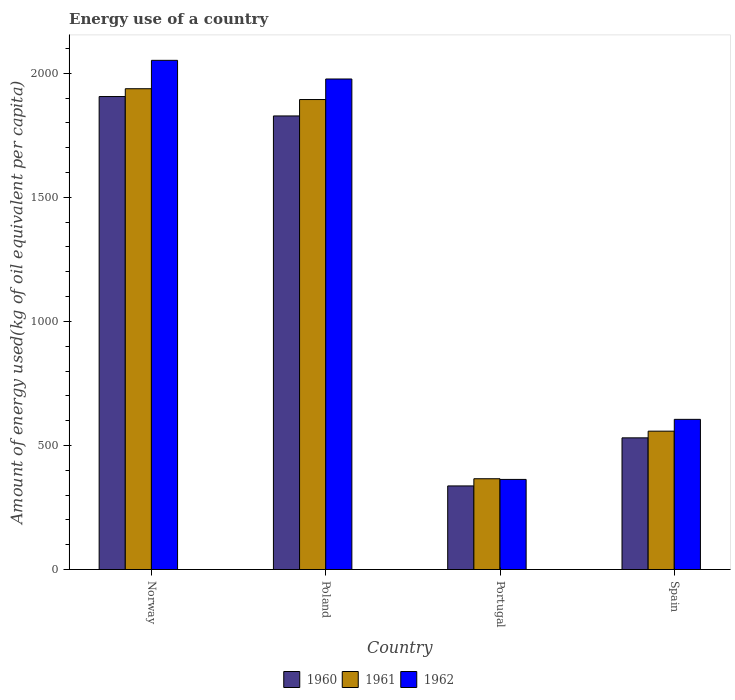How many groups of bars are there?
Give a very brief answer. 4. Are the number of bars per tick equal to the number of legend labels?
Your response must be concise. Yes. Are the number of bars on each tick of the X-axis equal?
Offer a terse response. Yes. How many bars are there on the 4th tick from the right?
Ensure brevity in your answer.  3. What is the label of the 3rd group of bars from the left?
Provide a short and direct response. Portugal. What is the amount of energy used in in 1961 in Poland?
Give a very brief answer. 1894.06. Across all countries, what is the maximum amount of energy used in in 1962?
Your answer should be compact. 2052.05. Across all countries, what is the minimum amount of energy used in in 1960?
Make the answer very short. 336.91. In which country was the amount of energy used in in 1962 minimum?
Make the answer very short. Portugal. What is the total amount of energy used in in 1961 in the graph?
Give a very brief answer. 4755.14. What is the difference between the amount of energy used in in 1962 in Poland and that in Portugal?
Your answer should be very brief. 1613.7. What is the difference between the amount of energy used in in 1962 in Poland and the amount of energy used in in 1960 in Spain?
Keep it short and to the point. 1446.19. What is the average amount of energy used in in 1961 per country?
Your answer should be very brief. 1188.79. What is the difference between the amount of energy used in of/in 1961 and amount of energy used in of/in 1960 in Poland?
Ensure brevity in your answer.  66.12. What is the ratio of the amount of energy used in in 1960 in Portugal to that in Spain?
Provide a short and direct response. 0.63. Is the amount of energy used in in 1961 in Poland less than that in Portugal?
Offer a terse response. No. What is the difference between the highest and the second highest amount of energy used in in 1962?
Provide a short and direct response. -75.19. What is the difference between the highest and the lowest amount of energy used in in 1960?
Ensure brevity in your answer.  1569.26. In how many countries, is the amount of energy used in in 1960 greater than the average amount of energy used in in 1960 taken over all countries?
Your answer should be very brief. 2. Is the sum of the amount of energy used in in 1960 in Poland and Portugal greater than the maximum amount of energy used in in 1961 across all countries?
Your answer should be very brief. Yes. What does the 1st bar from the left in Poland represents?
Provide a succinct answer. 1960. What does the 3rd bar from the right in Poland represents?
Provide a short and direct response. 1960. How many bars are there?
Offer a terse response. 12. Are the values on the major ticks of Y-axis written in scientific E-notation?
Your response must be concise. No. How are the legend labels stacked?
Provide a succinct answer. Horizontal. What is the title of the graph?
Your answer should be very brief. Energy use of a country. What is the label or title of the Y-axis?
Give a very brief answer. Amount of energy used(kg of oil equivalent per capita). What is the Amount of energy used(kg of oil equivalent per capita) of 1960 in Norway?
Provide a short and direct response. 1906.17. What is the Amount of energy used(kg of oil equivalent per capita) of 1961 in Norway?
Offer a very short reply. 1937.64. What is the Amount of energy used(kg of oil equivalent per capita) in 1962 in Norway?
Give a very brief answer. 2052.05. What is the Amount of energy used(kg of oil equivalent per capita) in 1960 in Poland?
Your answer should be very brief. 1827.94. What is the Amount of energy used(kg of oil equivalent per capita) in 1961 in Poland?
Ensure brevity in your answer.  1894.06. What is the Amount of energy used(kg of oil equivalent per capita) of 1962 in Poland?
Your answer should be compact. 1976.86. What is the Amount of energy used(kg of oil equivalent per capita) of 1960 in Portugal?
Ensure brevity in your answer.  336.91. What is the Amount of energy used(kg of oil equivalent per capita) in 1961 in Portugal?
Make the answer very short. 365.84. What is the Amount of energy used(kg of oil equivalent per capita) of 1962 in Portugal?
Provide a short and direct response. 363.16. What is the Amount of energy used(kg of oil equivalent per capita) of 1960 in Spain?
Your response must be concise. 530.66. What is the Amount of energy used(kg of oil equivalent per capita) in 1961 in Spain?
Your answer should be compact. 557.6. What is the Amount of energy used(kg of oil equivalent per capita) of 1962 in Spain?
Your answer should be compact. 605.22. Across all countries, what is the maximum Amount of energy used(kg of oil equivalent per capita) in 1960?
Offer a very short reply. 1906.17. Across all countries, what is the maximum Amount of energy used(kg of oil equivalent per capita) in 1961?
Keep it short and to the point. 1937.64. Across all countries, what is the maximum Amount of energy used(kg of oil equivalent per capita) of 1962?
Provide a short and direct response. 2052.05. Across all countries, what is the minimum Amount of energy used(kg of oil equivalent per capita) of 1960?
Your answer should be very brief. 336.91. Across all countries, what is the minimum Amount of energy used(kg of oil equivalent per capita) in 1961?
Offer a terse response. 365.84. Across all countries, what is the minimum Amount of energy used(kg of oil equivalent per capita) in 1962?
Your answer should be compact. 363.16. What is the total Amount of energy used(kg of oil equivalent per capita) of 1960 in the graph?
Offer a very short reply. 4601.69. What is the total Amount of energy used(kg of oil equivalent per capita) in 1961 in the graph?
Your answer should be compact. 4755.14. What is the total Amount of energy used(kg of oil equivalent per capita) of 1962 in the graph?
Offer a terse response. 4997.3. What is the difference between the Amount of energy used(kg of oil equivalent per capita) in 1960 in Norway and that in Poland?
Your answer should be very brief. 78.24. What is the difference between the Amount of energy used(kg of oil equivalent per capita) of 1961 in Norway and that in Poland?
Provide a succinct answer. 43.59. What is the difference between the Amount of energy used(kg of oil equivalent per capita) of 1962 in Norway and that in Poland?
Provide a short and direct response. 75.19. What is the difference between the Amount of energy used(kg of oil equivalent per capita) in 1960 in Norway and that in Portugal?
Your response must be concise. 1569.26. What is the difference between the Amount of energy used(kg of oil equivalent per capita) of 1961 in Norway and that in Portugal?
Keep it short and to the point. 1571.8. What is the difference between the Amount of energy used(kg of oil equivalent per capita) of 1962 in Norway and that in Portugal?
Give a very brief answer. 1688.89. What is the difference between the Amount of energy used(kg of oil equivalent per capita) in 1960 in Norway and that in Spain?
Offer a terse response. 1375.51. What is the difference between the Amount of energy used(kg of oil equivalent per capita) in 1961 in Norway and that in Spain?
Ensure brevity in your answer.  1380.05. What is the difference between the Amount of energy used(kg of oil equivalent per capita) of 1962 in Norway and that in Spain?
Ensure brevity in your answer.  1446.83. What is the difference between the Amount of energy used(kg of oil equivalent per capita) of 1960 in Poland and that in Portugal?
Make the answer very short. 1491.02. What is the difference between the Amount of energy used(kg of oil equivalent per capita) in 1961 in Poland and that in Portugal?
Ensure brevity in your answer.  1528.22. What is the difference between the Amount of energy used(kg of oil equivalent per capita) of 1962 in Poland and that in Portugal?
Offer a terse response. 1613.7. What is the difference between the Amount of energy used(kg of oil equivalent per capita) of 1960 in Poland and that in Spain?
Provide a succinct answer. 1297.27. What is the difference between the Amount of energy used(kg of oil equivalent per capita) in 1961 in Poland and that in Spain?
Your answer should be compact. 1336.46. What is the difference between the Amount of energy used(kg of oil equivalent per capita) of 1962 in Poland and that in Spain?
Your answer should be compact. 1371.64. What is the difference between the Amount of energy used(kg of oil equivalent per capita) in 1960 in Portugal and that in Spain?
Ensure brevity in your answer.  -193.75. What is the difference between the Amount of energy used(kg of oil equivalent per capita) of 1961 in Portugal and that in Spain?
Give a very brief answer. -191.76. What is the difference between the Amount of energy used(kg of oil equivalent per capita) of 1962 in Portugal and that in Spain?
Give a very brief answer. -242.06. What is the difference between the Amount of energy used(kg of oil equivalent per capita) in 1960 in Norway and the Amount of energy used(kg of oil equivalent per capita) in 1961 in Poland?
Ensure brevity in your answer.  12.12. What is the difference between the Amount of energy used(kg of oil equivalent per capita) in 1960 in Norway and the Amount of energy used(kg of oil equivalent per capita) in 1962 in Poland?
Offer a very short reply. -70.68. What is the difference between the Amount of energy used(kg of oil equivalent per capita) in 1961 in Norway and the Amount of energy used(kg of oil equivalent per capita) in 1962 in Poland?
Offer a very short reply. -39.22. What is the difference between the Amount of energy used(kg of oil equivalent per capita) of 1960 in Norway and the Amount of energy used(kg of oil equivalent per capita) of 1961 in Portugal?
Your response must be concise. 1540.33. What is the difference between the Amount of energy used(kg of oil equivalent per capita) of 1960 in Norway and the Amount of energy used(kg of oil equivalent per capita) of 1962 in Portugal?
Ensure brevity in your answer.  1543.01. What is the difference between the Amount of energy used(kg of oil equivalent per capita) of 1961 in Norway and the Amount of energy used(kg of oil equivalent per capita) of 1962 in Portugal?
Ensure brevity in your answer.  1574.48. What is the difference between the Amount of energy used(kg of oil equivalent per capita) in 1960 in Norway and the Amount of energy used(kg of oil equivalent per capita) in 1961 in Spain?
Your answer should be compact. 1348.58. What is the difference between the Amount of energy used(kg of oil equivalent per capita) of 1960 in Norway and the Amount of energy used(kg of oil equivalent per capita) of 1962 in Spain?
Give a very brief answer. 1300.95. What is the difference between the Amount of energy used(kg of oil equivalent per capita) in 1961 in Norway and the Amount of energy used(kg of oil equivalent per capita) in 1962 in Spain?
Keep it short and to the point. 1332.42. What is the difference between the Amount of energy used(kg of oil equivalent per capita) in 1960 in Poland and the Amount of energy used(kg of oil equivalent per capita) in 1961 in Portugal?
Your response must be concise. 1462.1. What is the difference between the Amount of energy used(kg of oil equivalent per capita) of 1960 in Poland and the Amount of energy used(kg of oil equivalent per capita) of 1962 in Portugal?
Provide a short and direct response. 1464.77. What is the difference between the Amount of energy used(kg of oil equivalent per capita) of 1961 in Poland and the Amount of energy used(kg of oil equivalent per capita) of 1962 in Portugal?
Keep it short and to the point. 1530.89. What is the difference between the Amount of energy used(kg of oil equivalent per capita) in 1960 in Poland and the Amount of energy used(kg of oil equivalent per capita) in 1961 in Spain?
Offer a very short reply. 1270.34. What is the difference between the Amount of energy used(kg of oil equivalent per capita) in 1960 in Poland and the Amount of energy used(kg of oil equivalent per capita) in 1962 in Spain?
Offer a terse response. 1222.71. What is the difference between the Amount of energy used(kg of oil equivalent per capita) in 1961 in Poland and the Amount of energy used(kg of oil equivalent per capita) in 1962 in Spain?
Keep it short and to the point. 1288.83. What is the difference between the Amount of energy used(kg of oil equivalent per capita) of 1960 in Portugal and the Amount of energy used(kg of oil equivalent per capita) of 1961 in Spain?
Offer a very short reply. -220.69. What is the difference between the Amount of energy used(kg of oil equivalent per capita) of 1960 in Portugal and the Amount of energy used(kg of oil equivalent per capita) of 1962 in Spain?
Provide a short and direct response. -268.31. What is the difference between the Amount of energy used(kg of oil equivalent per capita) in 1961 in Portugal and the Amount of energy used(kg of oil equivalent per capita) in 1962 in Spain?
Offer a terse response. -239.38. What is the average Amount of energy used(kg of oil equivalent per capita) in 1960 per country?
Offer a very short reply. 1150.42. What is the average Amount of energy used(kg of oil equivalent per capita) of 1961 per country?
Make the answer very short. 1188.79. What is the average Amount of energy used(kg of oil equivalent per capita) of 1962 per country?
Ensure brevity in your answer.  1249.33. What is the difference between the Amount of energy used(kg of oil equivalent per capita) in 1960 and Amount of energy used(kg of oil equivalent per capita) in 1961 in Norway?
Provide a short and direct response. -31.47. What is the difference between the Amount of energy used(kg of oil equivalent per capita) of 1960 and Amount of energy used(kg of oil equivalent per capita) of 1962 in Norway?
Offer a very short reply. -145.88. What is the difference between the Amount of energy used(kg of oil equivalent per capita) of 1961 and Amount of energy used(kg of oil equivalent per capita) of 1962 in Norway?
Your response must be concise. -114.41. What is the difference between the Amount of energy used(kg of oil equivalent per capita) in 1960 and Amount of energy used(kg of oil equivalent per capita) in 1961 in Poland?
Your answer should be compact. -66.12. What is the difference between the Amount of energy used(kg of oil equivalent per capita) of 1960 and Amount of energy used(kg of oil equivalent per capita) of 1962 in Poland?
Ensure brevity in your answer.  -148.92. What is the difference between the Amount of energy used(kg of oil equivalent per capita) of 1961 and Amount of energy used(kg of oil equivalent per capita) of 1962 in Poland?
Give a very brief answer. -82.8. What is the difference between the Amount of energy used(kg of oil equivalent per capita) in 1960 and Amount of energy used(kg of oil equivalent per capita) in 1961 in Portugal?
Your response must be concise. -28.93. What is the difference between the Amount of energy used(kg of oil equivalent per capita) in 1960 and Amount of energy used(kg of oil equivalent per capita) in 1962 in Portugal?
Your response must be concise. -26.25. What is the difference between the Amount of energy used(kg of oil equivalent per capita) of 1961 and Amount of energy used(kg of oil equivalent per capita) of 1962 in Portugal?
Offer a very short reply. 2.68. What is the difference between the Amount of energy used(kg of oil equivalent per capita) of 1960 and Amount of energy used(kg of oil equivalent per capita) of 1961 in Spain?
Your answer should be very brief. -26.93. What is the difference between the Amount of energy used(kg of oil equivalent per capita) of 1960 and Amount of energy used(kg of oil equivalent per capita) of 1962 in Spain?
Provide a short and direct response. -74.56. What is the difference between the Amount of energy used(kg of oil equivalent per capita) of 1961 and Amount of energy used(kg of oil equivalent per capita) of 1962 in Spain?
Provide a succinct answer. -47.62. What is the ratio of the Amount of energy used(kg of oil equivalent per capita) of 1960 in Norway to that in Poland?
Offer a very short reply. 1.04. What is the ratio of the Amount of energy used(kg of oil equivalent per capita) of 1962 in Norway to that in Poland?
Provide a short and direct response. 1.04. What is the ratio of the Amount of energy used(kg of oil equivalent per capita) of 1960 in Norway to that in Portugal?
Provide a short and direct response. 5.66. What is the ratio of the Amount of energy used(kg of oil equivalent per capita) of 1961 in Norway to that in Portugal?
Your answer should be compact. 5.3. What is the ratio of the Amount of energy used(kg of oil equivalent per capita) of 1962 in Norway to that in Portugal?
Provide a short and direct response. 5.65. What is the ratio of the Amount of energy used(kg of oil equivalent per capita) of 1960 in Norway to that in Spain?
Provide a succinct answer. 3.59. What is the ratio of the Amount of energy used(kg of oil equivalent per capita) of 1961 in Norway to that in Spain?
Ensure brevity in your answer.  3.48. What is the ratio of the Amount of energy used(kg of oil equivalent per capita) of 1962 in Norway to that in Spain?
Ensure brevity in your answer.  3.39. What is the ratio of the Amount of energy used(kg of oil equivalent per capita) of 1960 in Poland to that in Portugal?
Keep it short and to the point. 5.43. What is the ratio of the Amount of energy used(kg of oil equivalent per capita) of 1961 in Poland to that in Portugal?
Offer a terse response. 5.18. What is the ratio of the Amount of energy used(kg of oil equivalent per capita) of 1962 in Poland to that in Portugal?
Ensure brevity in your answer.  5.44. What is the ratio of the Amount of energy used(kg of oil equivalent per capita) in 1960 in Poland to that in Spain?
Provide a succinct answer. 3.44. What is the ratio of the Amount of energy used(kg of oil equivalent per capita) in 1961 in Poland to that in Spain?
Offer a terse response. 3.4. What is the ratio of the Amount of energy used(kg of oil equivalent per capita) in 1962 in Poland to that in Spain?
Offer a terse response. 3.27. What is the ratio of the Amount of energy used(kg of oil equivalent per capita) of 1960 in Portugal to that in Spain?
Your answer should be very brief. 0.63. What is the ratio of the Amount of energy used(kg of oil equivalent per capita) of 1961 in Portugal to that in Spain?
Keep it short and to the point. 0.66. What is the ratio of the Amount of energy used(kg of oil equivalent per capita) of 1962 in Portugal to that in Spain?
Provide a succinct answer. 0.6. What is the difference between the highest and the second highest Amount of energy used(kg of oil equivalent per capita) of 1960?
Keep it short and to the point. 78.24. What is the difference between the highest and the second highest Amount of energy used(kg of oil equivalent per capita) of 1961?
Offer a terse response. 43.59. What is the difference between the highest and the second highest Amount of energy used(kg of oil equivalent per capita) in 1962?
Provide a succinct answer. 75.19. What is the difference between the highest and the lowest Amount of energy used(kg of oil equivalent per capita) in 1960?
Offer a terse response. 1569.26. What is the difference between the highest and the lowest Amount of energy used(kg of oil equivalent per capita) in 1961?
Your answer should be compact. 1571.8. What is the difference between the highest and the lowest Amount of energy used(kg of oil equivalent per capita) in 1962?
Offer a very short reply. 1688.89. 